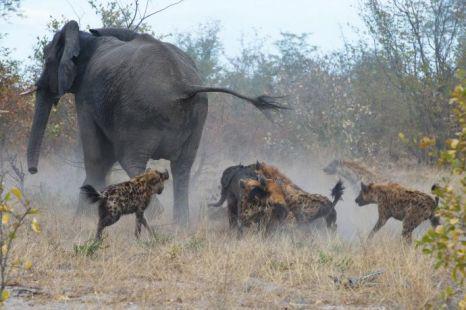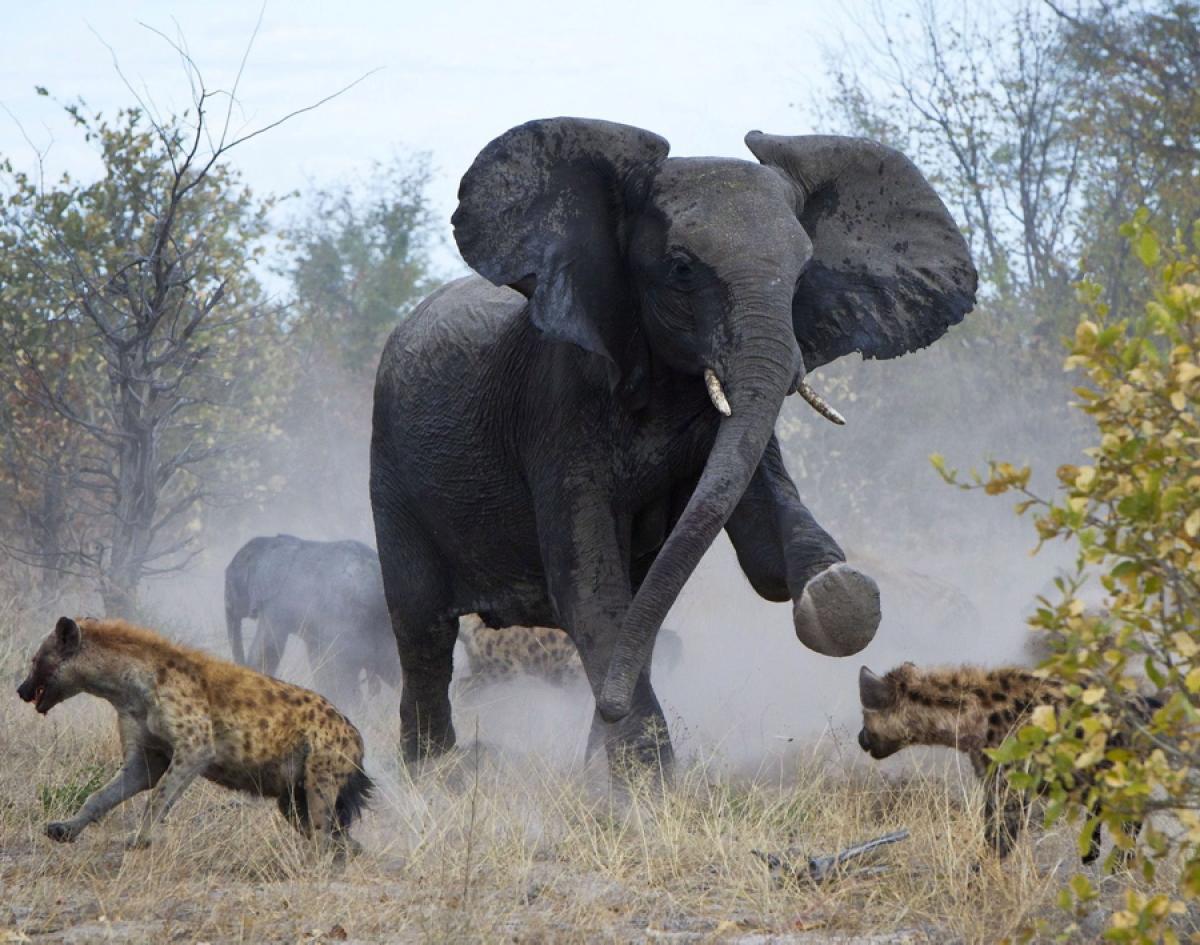The first image is the image on the left, the second image is the image on the right. For the images displayed, is the sentence "The animal in the image on the right is carrying an elephant foot." factually correct? Answer yes or no. No. 